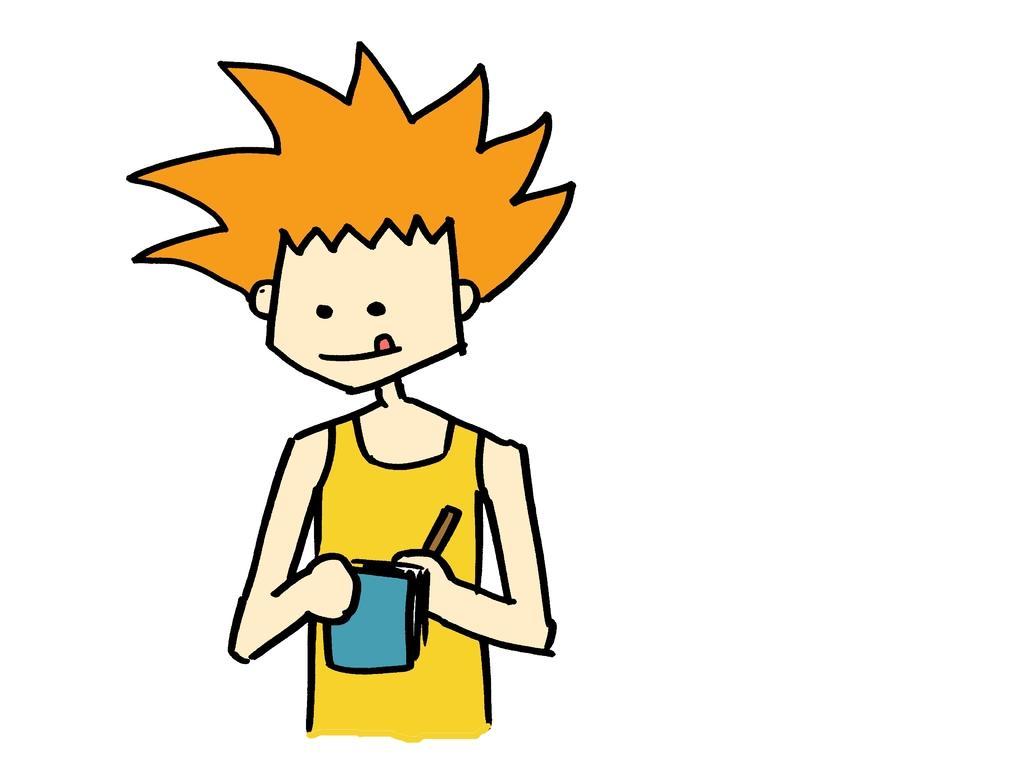In one or two sentences, can you explain what this image depicts? Here we can see a cartoon image and the person is holding a cup and an object in his hands. 